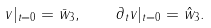<formula> <loc_0><loc_0><loc_500><loc_500>v | _ { t = 0 } = \bar { w } _ { 3 } , \quad \partial _ { t } v | _ { t = 0 } = \hat { w } _ { 3 } .</formula> 